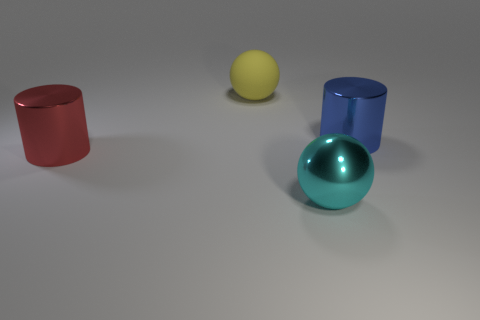Add 3 yellow rubber objects. How many objects exist? 7 Add 4 tiny cyan cubes. How many tiny cyan cubes exist? 4 Subtract 1 blue cylinders. How many objects are left? 3 Subtract all tiny blue matte blocks. Subtract all big matte objects. How many objects are left? 3 Add 4 shiny spheres. How many shiny spheres are left? 5 